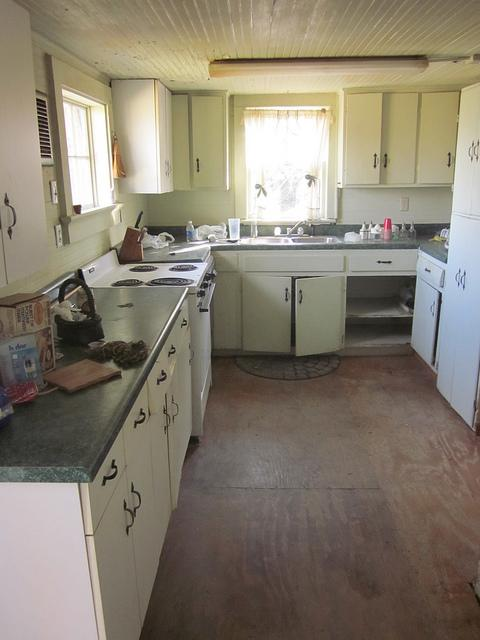What is the black and white object to the left of the window?

Choices:
A) vent
B) iron decoration
C) picture
D) pan vent 